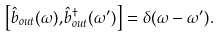Convert formula to latex. <formula><loc_0><loc_0><loc_500><loc_500>\left [ \hat { b } _ { o u t } ( \omega ) , \hat { b } _ { o u t } ^ { \dagger } ( \omega ^ { \prime } ) \right ] = \delta ( \omega - \omega ^ { \prime } ) .</formula> 